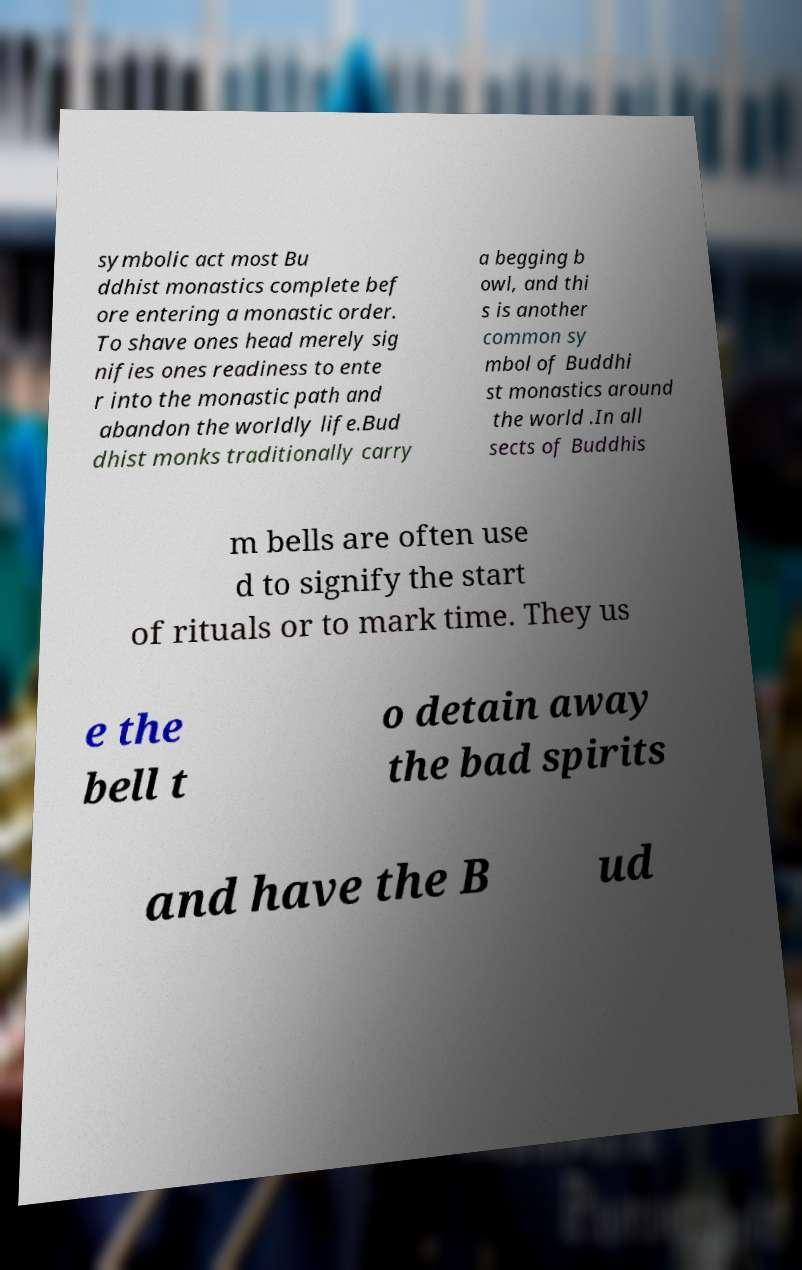For documentation purposes, I need the text within this image transcribed. Could you provide that? symbolic act most Bu ddhist monastics complete bef ore entering a monastic order. To shave ones head merely sig nifies ones readiness to ente r into the monastic path and abandon the worldly life.Bud dhist monks traditionally carry a begging b owl, and thi s is another common sy mbol of Buddhi st monastics around the world .In all sects of Buddhis m bells are often use d to signify the start of rituals or to mark time. They us e the bell t o detain away the bad spirits and have the B ud 